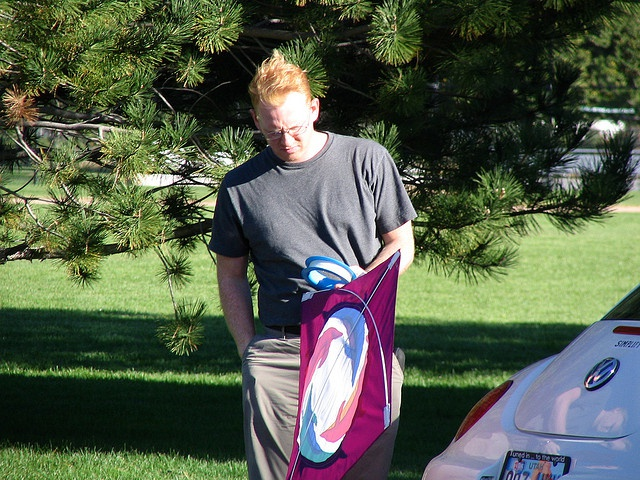Describe the objects in this image and their specific colors. I can see people in darkgreen, black, darkgray, white, and gray tones, car in darkgreen, gray, darkgray, and black tones, and kite in darkgreen, purple, white, and navy tones in this image. 